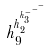<formula> <loc_0><loc_0><loc_500><loc_500>h _ { 9 } ^ { h _ { 2 } ^ { h _ { 3 } ^ { - ^ { - ^ { - } } } } }</formula> 